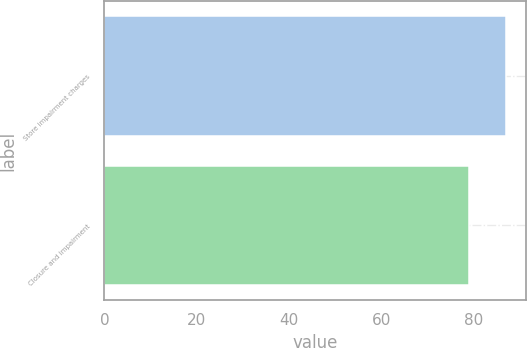<chart> <loc_0><loc_0><loc_500><loc_500><bar_chart><fcel>Store impairment charges<fcel>Closure and impairment<nl><fcel>87<fcel>79<nl></chart> 